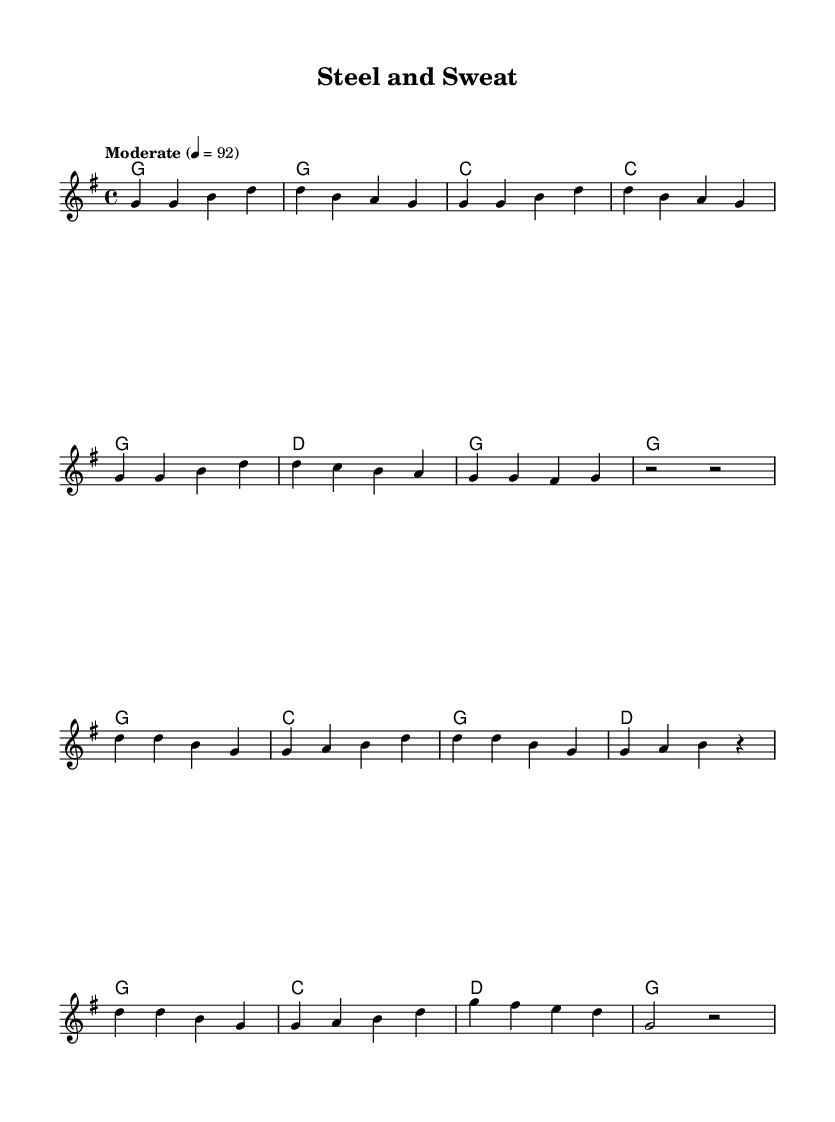what is the key signature of this music? The key signature is indicated at the beginning of the staff. It’s G major, which has one sharp.
Answer: G major what is the time signature of this music? The time signature is shown at the beginning of the score. It indicates there are four beats in each measure.
Answer: 4/4 what is the tempo marking for this piece? The tempo marking is shown at the beginning and indicates how fast the piece should be played. It states "Moderate" with a specific metronome marking of 92 beats per minute.
Answer: Moderate how many measures are in the verse section? To find this, we count the measures in the melody and lyrics specifically for the verse section. There are eight measures in total for the verse.
Answer: 8 which section starts with "Steel and sweat, that's our world"? This phrase is part of the lyrics in the chorus section, which is clearly marked after the verse.
Answer: Chorus how many unique chords are used in the verse? By analyzing the chord progression given in the harmonies for the verse, we can identify the unique chords used. The unique chords are G, C, and D. Therefore, there are three unique chords.
Answer: 3 what theme is presented in the song's lyrics? The lyrics express themes commonly found in country music, focusing on hard work and factory life. They reflect toil, resilience, and the value of labor.
Answer: Hard work 